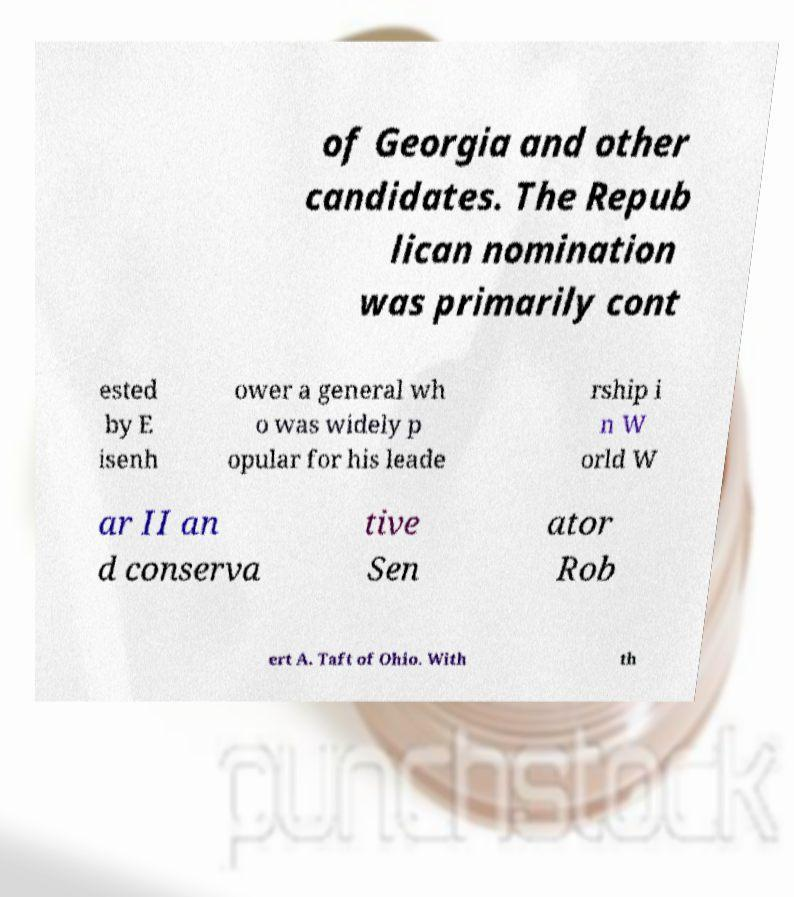Can you read and provide the text displayed in the image?This photo seems to have some interesting text. Can you extract and type it out for me? of Georgia and other candidates. The Repub lican nomination was primarily cont ested by E isenh ower a general wh o was widely p opular for his leade rship i n W orld W ar II an d conserva tive Sen ator Rob ert A. Taft of Ohio. With th 